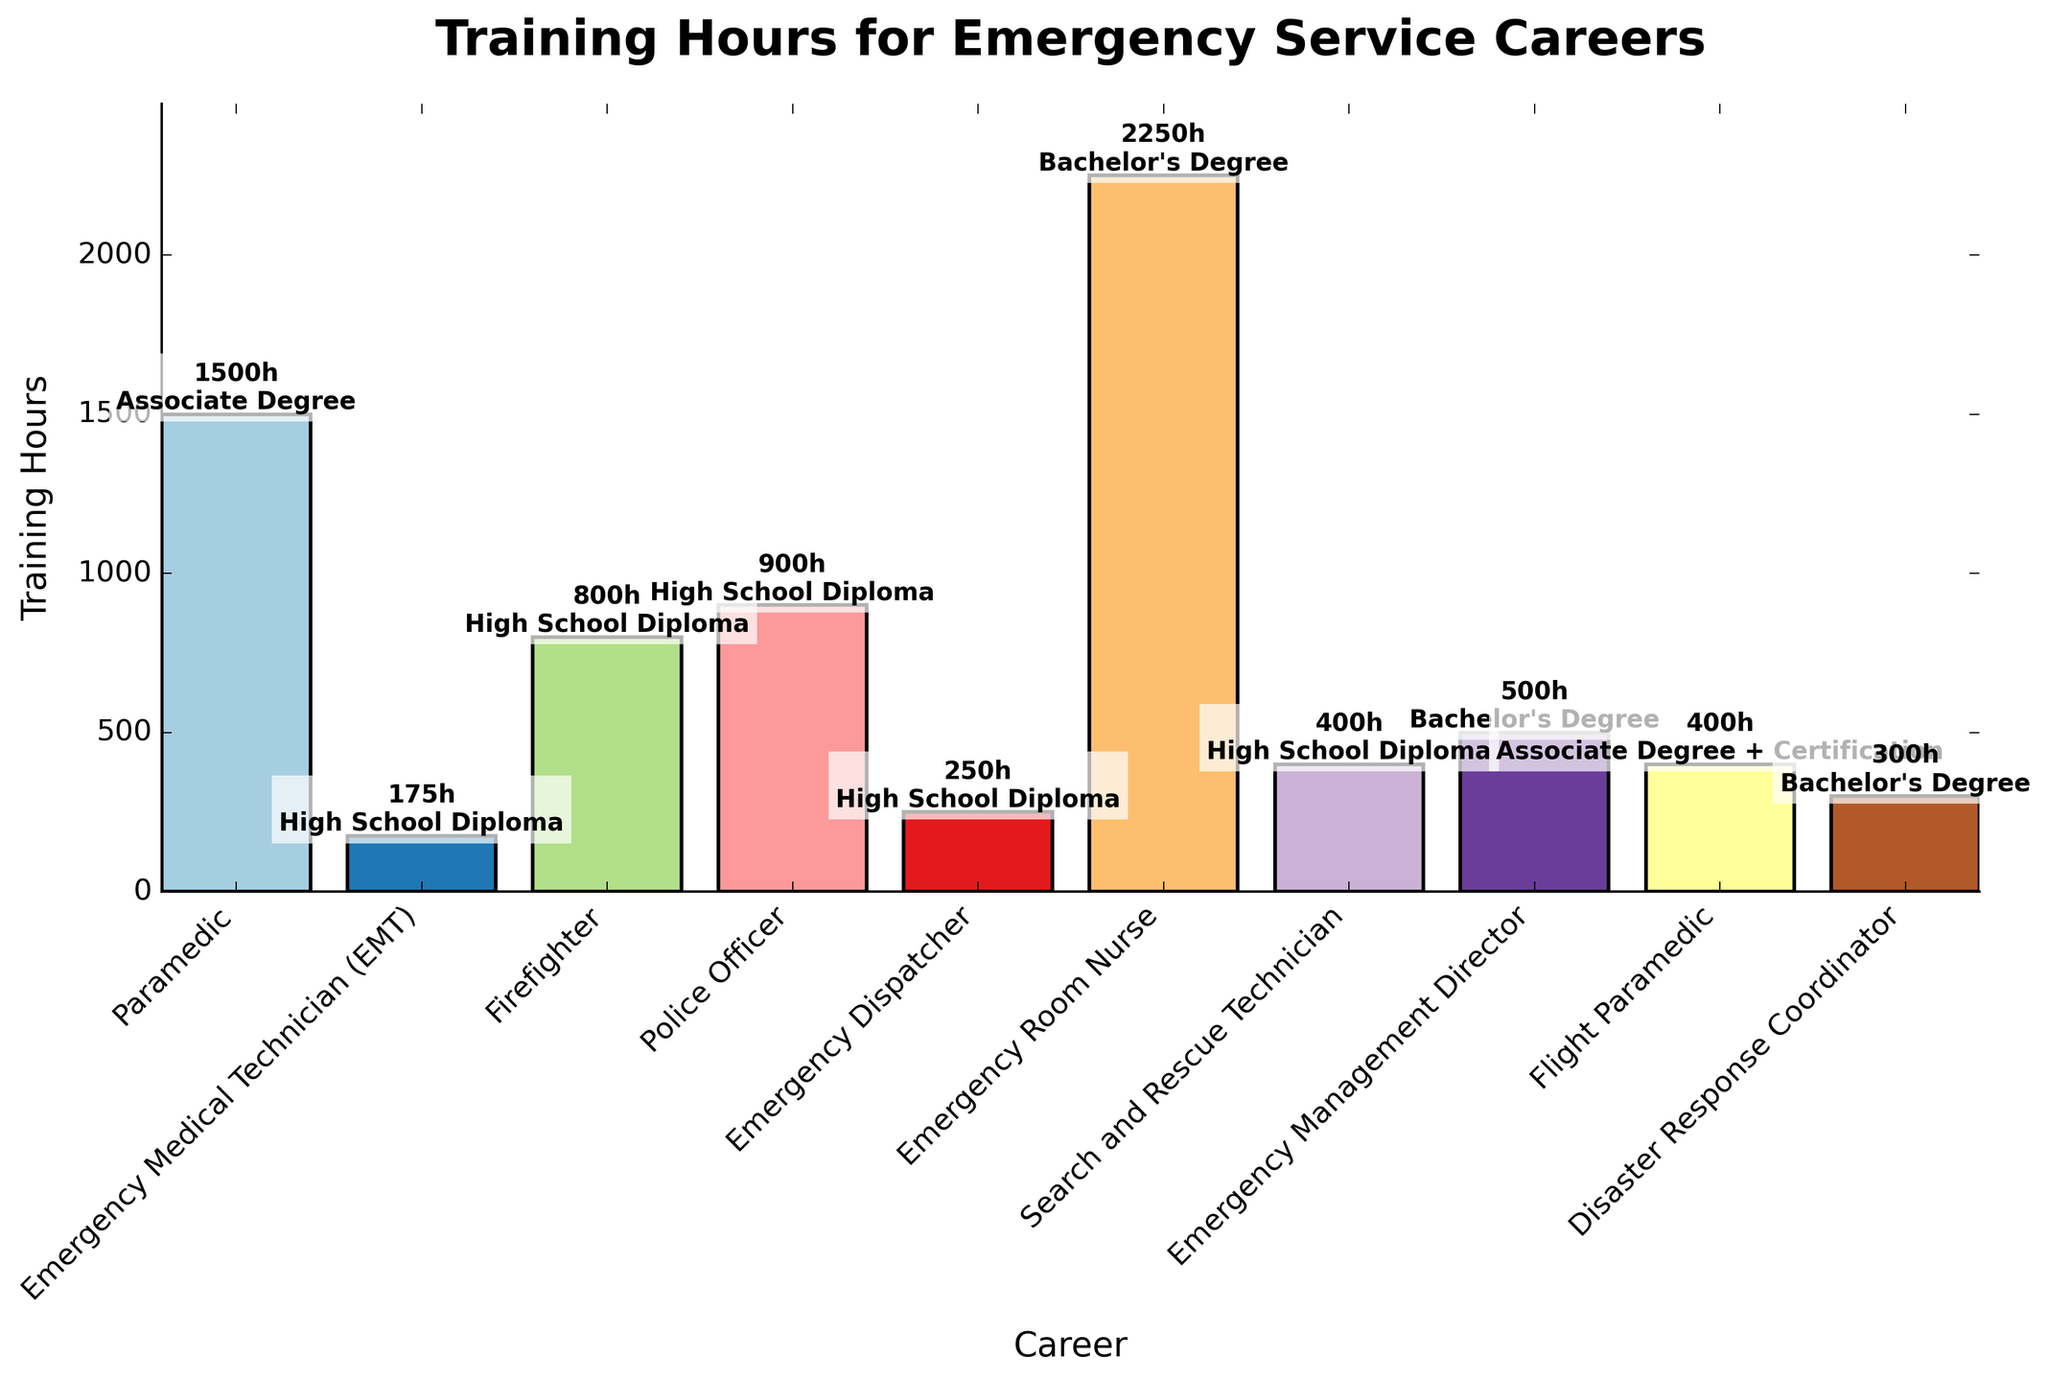What's the career with the highest average training hours? The bar chart shows the average training hours for each career. By visually inspecting the heights of the bars, Emergency Room Nurse has the tallest bar.
Answer: Emergency Room Nurse Which career requires less training hours on average, EMT or Emergency Dispatcher? By comparing the heights of the bars for EMT and Emergency Dispatcher, we see that EMT has a bar between 150-200, whereas Emergency Dispatcher is between 200-300. Thus, EMT requires less training hours on average.
Answer: EMT What's the average training hours for a Paramedic? According to the chart, the training hours for a Paramedic are labeled as 1200-1800 hours. By taking the mean of 1200 and 1800, we get (1200 + 1800)/2 = 1500.
Answer: 1500 How does the training hours of a Search and Rescue Technician compare to that of a Flight Paramedic? The bar for Search and Rescue Technician is labeled as 300-500 hours, and the bar for Flight Paramedic is labeled as 300-500 hours. Both have the same average training hours.
Answer: Equal Which career listed requires the minimum education of an Associate Degree? By looking at the text labels above the bars, only Paramedic and Flight Paramedic have "Associate Degree" as their minimum education requirement.
Answer: Paramedic, Flight Paramedic What is the difference in average training hours between a Police Officer and an Emergency Management Director? The average for Police Officer is (800+1000)/2 = 900 hours, and for Emergency Management Director, it is (400+600)/2 = 500 hours. The difference is 900 - 500 = 400 hours.
Answer: 400 Which career has a higher average training hours, Firefighter or Disaster Response Coordinator? By comparing the bars, Firefighter has an average training of (600+1000)/2 = 800 hours, and Disaster Response Coordinator has (200+400)/2 = 300 hours. Firefighter has a higher average training hours.
Answer: Firefighter What color is the bar representing Emergency Room Nurse? The bar chart uses different colors for each career. The color bar representing Emergency Room Nurse is visually blue.
Answer: Blue What's the combined total of average training hours for EMT, Firefighter, and Search and Rescue Technician? The averages are 175 hours for EMT, 800 hours for Firefighter, and 400 hours for Search and Rescue Technician. Adding these gives 175 + 800 + 400 = 1375 hours.
Answer: 1375 Which career requires the minimum number of training hours within the data provided? The lowest bar indicating training hours is for EMT, which ranges from 150-200 hours.
Answer: EMT 